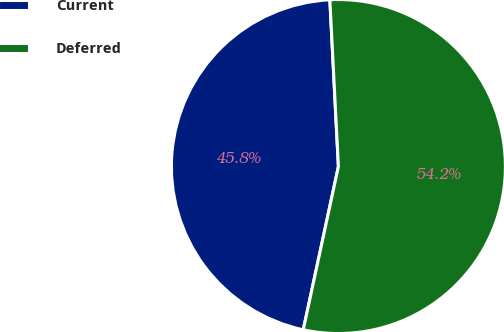<chart> <loc_0><loc_0><loc_500><loc_500><pie_chart><fcel>Current<fcel>Deferred<nl><fcel>45.81%<fcel>54.19%<nl></chart> 